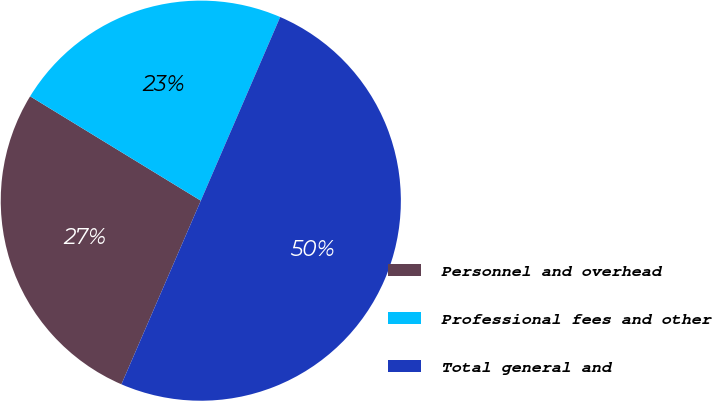Convert chart. <chart><loc_0><loc_0><loc_500><loc_500><pie_chart><fcel>Personnel and overhead<fcel>Professional fees and other<fcel>Total general and<nl><fcel>27.24%<fcel>22.76%<fcel>50.0%<nl></chart> 